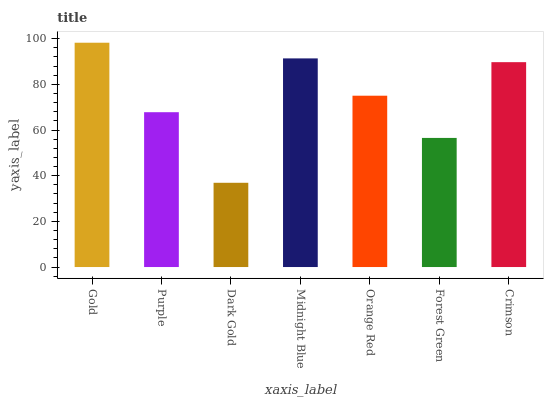Is Dark Gold the minimum?
Answer yes or no. Yes. Is Gold the maximum?
Answer yes or no. Yes. Is Purple the minimum?
Answer yes or no. No. Is Purple the maximum?
Answer yes or no. No. Is Gold greater than Purple?
Answer yes or no. Yes. Is Purple less than Gold?
Answer yes or no. Yes. Is Purple greater than Gold?
Answer yes or no. No. Is Gold less than Purple?
Answer yes or no. No. Is Orange Red the high median?
Answer yes or no. Yes. Is Orange Red the low median?
Answer yes or no. Yes. Is Purple the high median?
Answer yes or no. No. Is Gold the low median?
Answer yes or no. No. 